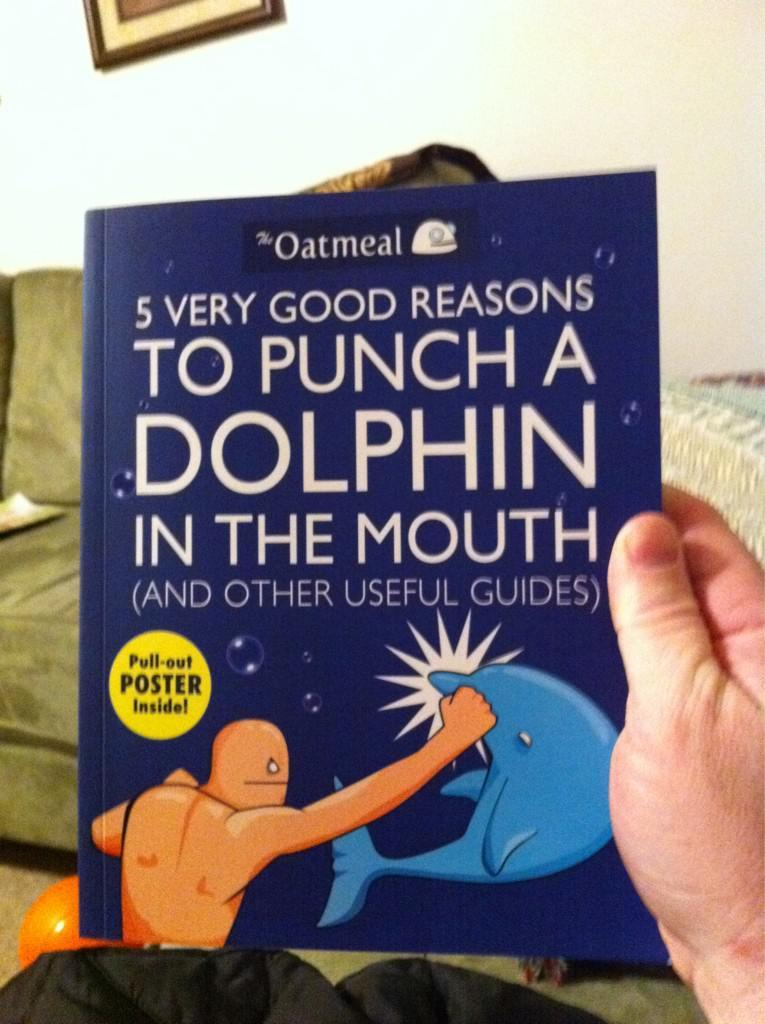Provide a one-sentence caption for the provided image. Someone is holding a book that has a pull-out poster inside. 